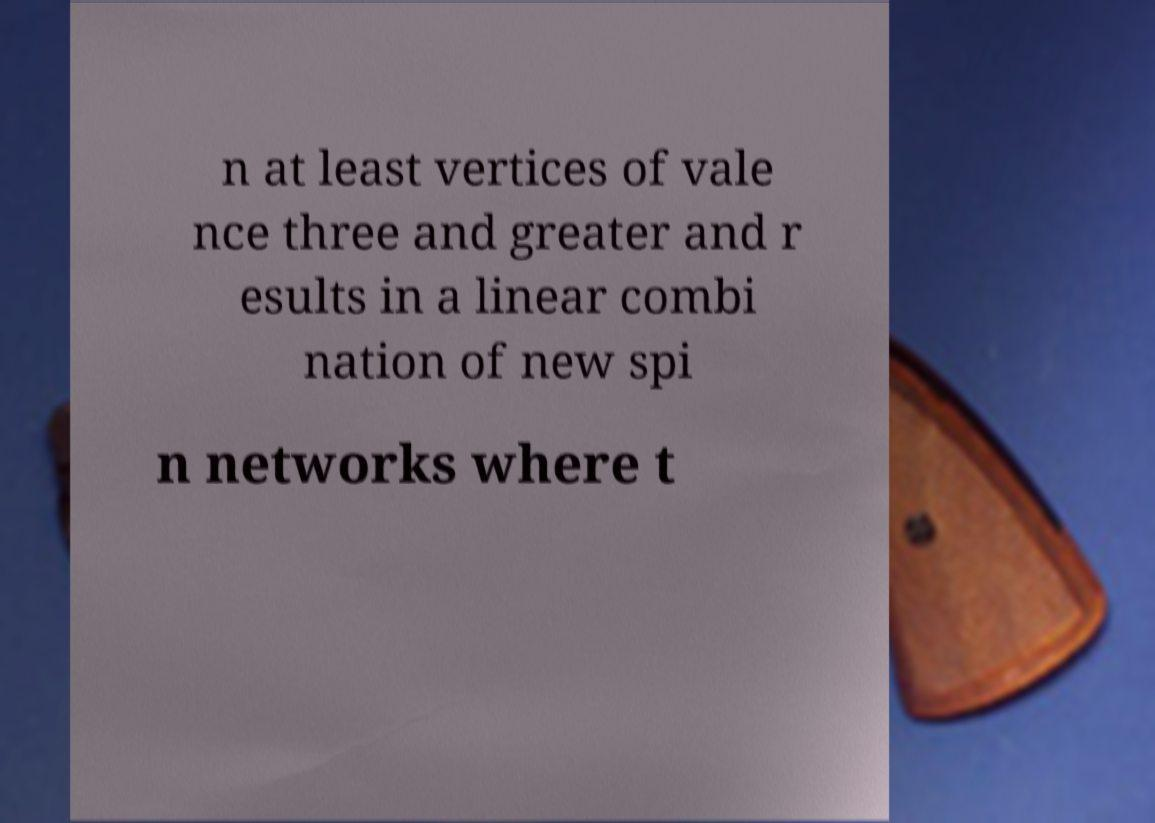What messages or text are displayed in this image? I need them in a readable, typed format. n at least vertices of vale nce three and greater and r esults in a linear combi nation of new spi n networks where t 